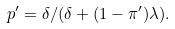<formula> <loc_0><loc_0><loc_500><loc_500>p ^ { \prime } = \delta / ( \delta + ( 1 - \pi ^ { \prime } ) \lambda ) .</formula> 